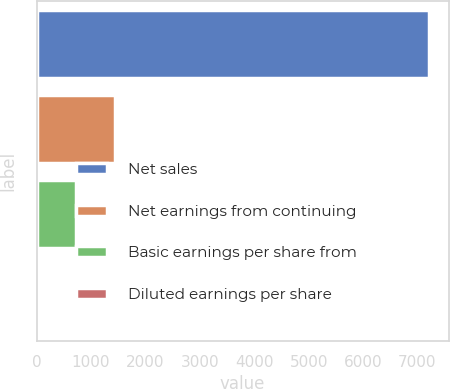Convert chart. <chart><loc_0><loc_0><loc_500><loc_500><bar_chart><fcel>Net sales<fcel>Net earnings from continuing<fcel>Basic earnings per share from<fcel>Diluted earnings per share<nl><fcel>7214.4<fcel>1444.55<fcel>723.32<fcel>2.09<nl></chart> 